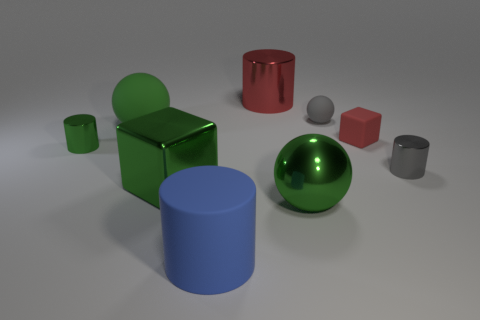Subtract all metallic cylinders. How many cylinders are left? 1 Subtract all cyan cubes. How many green balls are left? 2 Add 1 gray cylinders. How many objects exist? 10 Subtract all blocks. How many objects are left? 7 Subtract all gray balls. How many balls are left? 2 Subtract 2 cylinders. How many cylinders are left? 2 Add 2 large blocks. How many large blocks exist? 3 Subtract 0 brown cylinders. How many objects are left? 9 Subtract all cyan cubes. Subtract all brown balls. How many cubes are left? 2 Subtract all small red objects. Subtract all large yellow things. How many objects are left? 8 